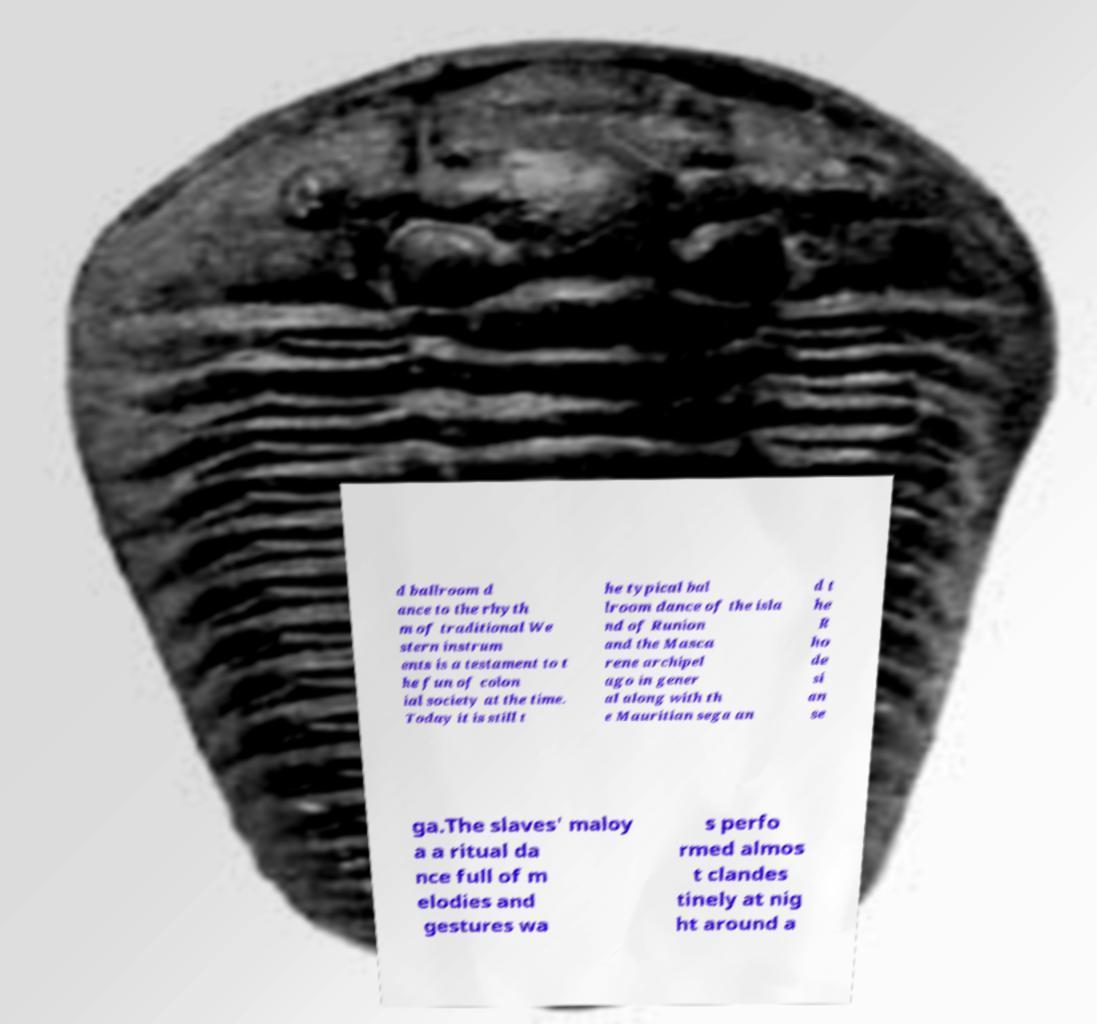Could you assist in decoding the text presented in this image and type it out clearly? d ballroom d ance to the rhyth m of traditional We stern instrum ents is a testament to t he fun of colon ial society at the time. Today it is still t he typical bal lroom dance of the isla nd of Runion and the Masca rene archipel ago in gener al along with th e Mauritian sega an d t he R ho de si an se ga.The slaves' maloy a a ritual da nce full of m elodies and gestures wa s perfo rmed almos t clandes tinely at nig ht around a 